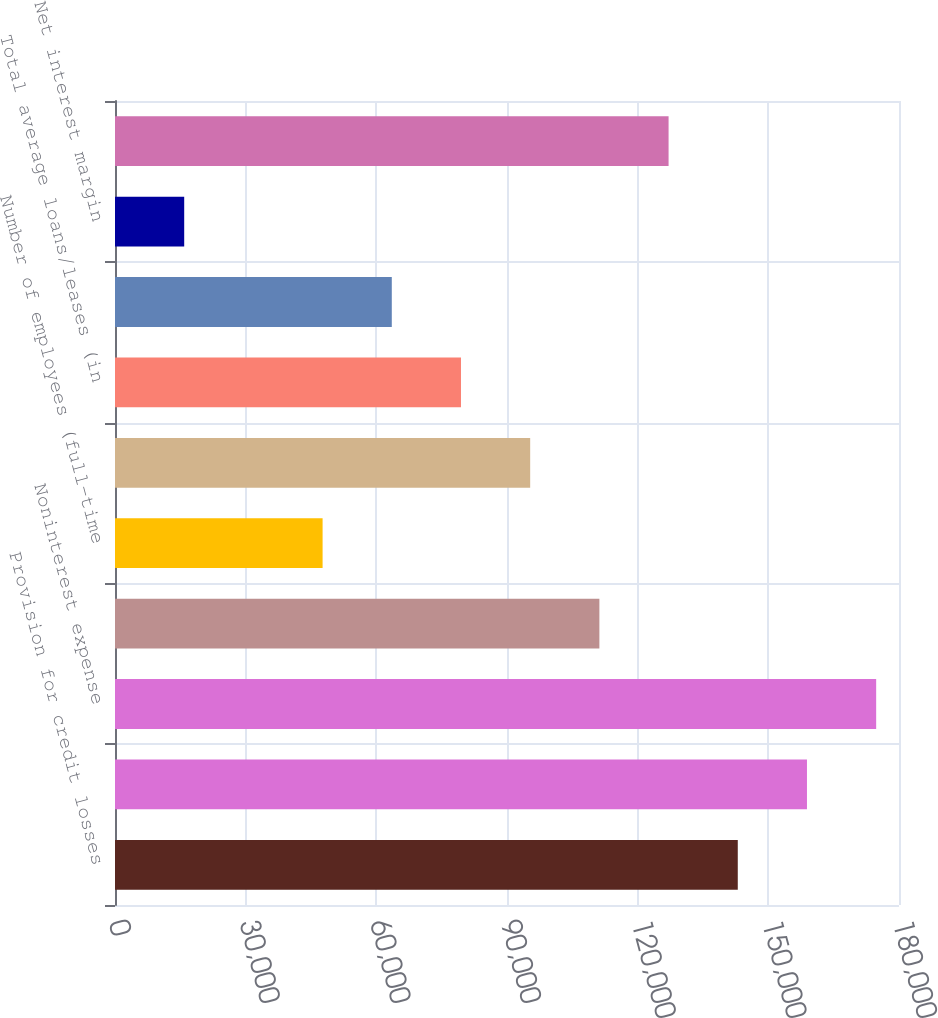<chart> <loc_0><loc_0><loc_500><loc_500><bar_chart><fcel>Provision for credit losses<fcel>Noninterest income<fcel>Noninterest expense<fcel>Provision (benefit) for income<fcel>Number of employees (full-time<fcel>Total average assets (in<fcel>Total average loans/leases (in<fcel>Total average deposits (in<fcel>Net interest margin<fcel>NCOs<nl><fcel>142984<fcel>158871<fcel>174758<fcel>111210<fcel>47661.9<fcel>95322.9<fcel>79435.9<fcel>63548.9<fcel>15887.9<fcel>127097<nl></chart> 